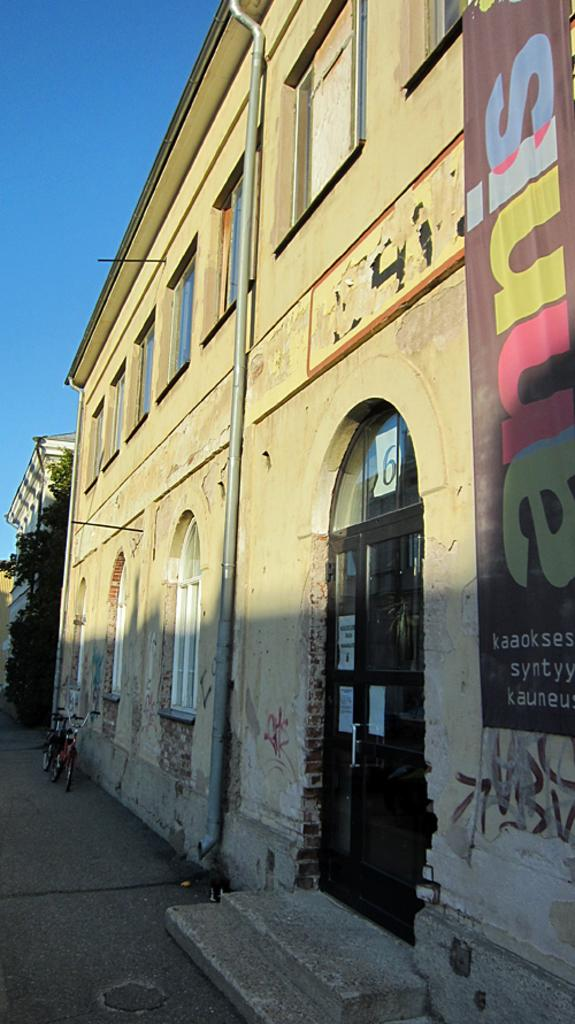What type of structures are visible in the image? There are buildings with windows in the image. What mode of transportation can be seen parked in the image? Bicycles are parked aside in the image. What type of vegetation is present in the image? There are trees in the image. What is written or displayed on the banner in the image? There is a banner with text in the image. What part of the natural environment is visible in the image? The sky is visible in the image. How many needles are used to create the trees in the image? There are no needles used to create the trees in the image; they are depicted as natural vegetation. What type of yard is visible in the image? There is no yard present in the image; it features buildings, bicycles, trees, a banner, and the sky. 